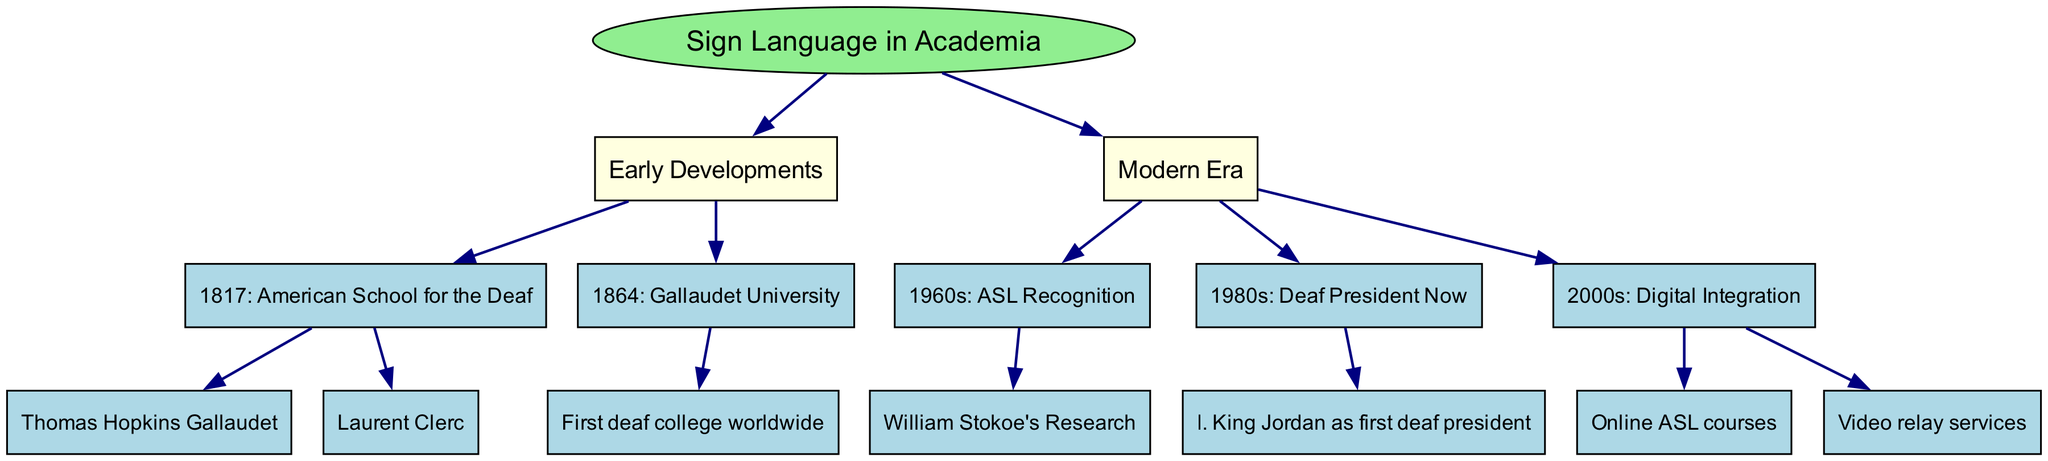What is the root of the family tree? The root of the diagram is labeled "Sign Language in Academia." It is the topmost node that branches out to the main categories of early developments and modern era.
Answer: Sign Language in Academia How many children does the "Early Developments" branch have? The "Early Developments" branch has two children: "1817: American School for the Deaf" and "1864: Gallaudet University." Counting these gives us a total of two children.
Answer: 2 Who is associated with the "1817: American School for the Deaf"? The node "1817: American School for the Deaf" has two children, which are "Thomas Hopkins Gallaudet" and "Laurent Clerc." Both of these individuals are associated with this historical event in the diagram.
Answer: Thomas Hopkins Gallaudet, Laurent Clerc What event does "I. King Jordan" correspond to? In the diagram, "I. King Jordan" is listed as a child of the "1980s: Deaf President Now" branch, indicating his significant role in that specific historical context focused on Deaf leadership.
Answer: 1980s: Deaf President Now Which node corresponds to the recognition of ASL? The node titled "1960s: ASL Recognition" specifically addresses the recognition of American Sign Language (ASL) and indicates the time frame when this acknowledgment occurred in academia, represented by a single branch in the diagram.
Answer: 1960s: ASL Recognition What is one of the children under "2000s: Digital Integration"? The node "2000s: Digital Integration" has two children: "Online ASL courses" and "Video relay services." Both represent key advancements in technology that impact sign language education and accessibility.
Answer: Online ASL courses What year corresponds to the establishment of Gallaudet University? The establishment is associated with the year "1864," which is clearly stated in the diagram under the branch "Early Developments." This date marks a significant milestone in the history of Deaf education.
Answer: 1864 Which individual is recognized for significant research in the 1960s? The diagram points to "William Stokoe's Research" under the branch "1960s: ASL Recognition," indicating that he is the notable figure associated with research that contributed to the recognition of ASL during that period.
Answer: William Stokoe's Research What is the significance of the "First deaf college worldwide"? The phrase "First deaf college worldwide" specifically describes Gallaudet University as established in 1864, indicating its historical importance as a leading institution for Deaf education, which is a key point highlighted in the diagram.
Answer: First deaf college worldwide 